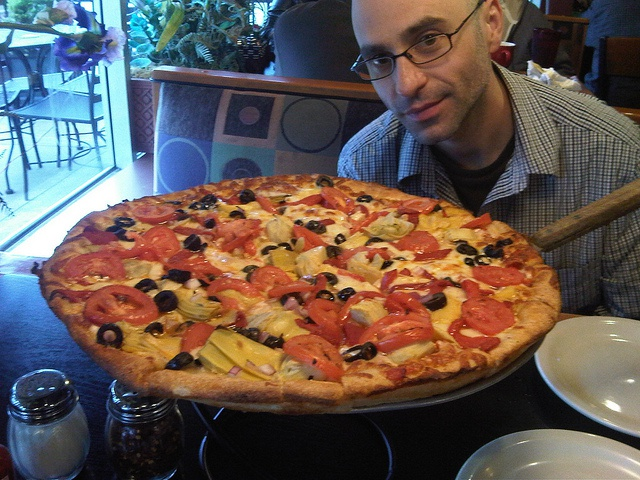Describe the objects in this image and their specific colors. I can see pizza in gray, brown, tan, and maroon tones, people in gray, black, and maroon tones, chair in gray, black, and navy tones, dining table in gray, black, navy, blue, and lightblue tones, and chair in gray, lightblue, and blue tones in this image. 